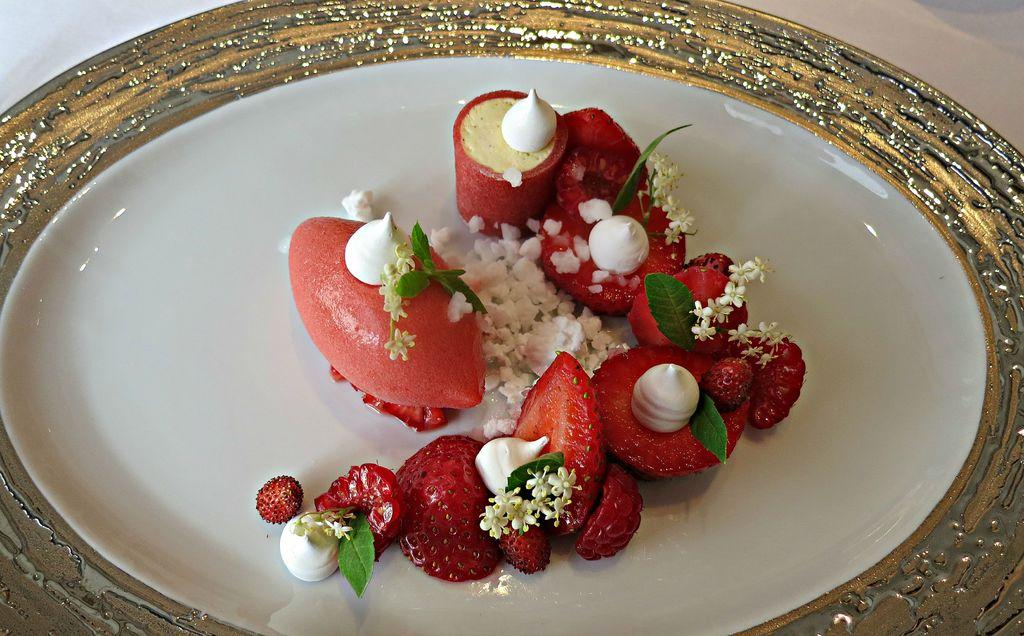What type of food is visible in the image? There is a salad in the image. How is the salad presented? The salad is in a plate. Where is the plate with the salad located? The plate with the salad is placed on a table. What type of jam is spread on the beef in the image? There is no jam or beef present in the image; it features a salad in a plate on a table. 